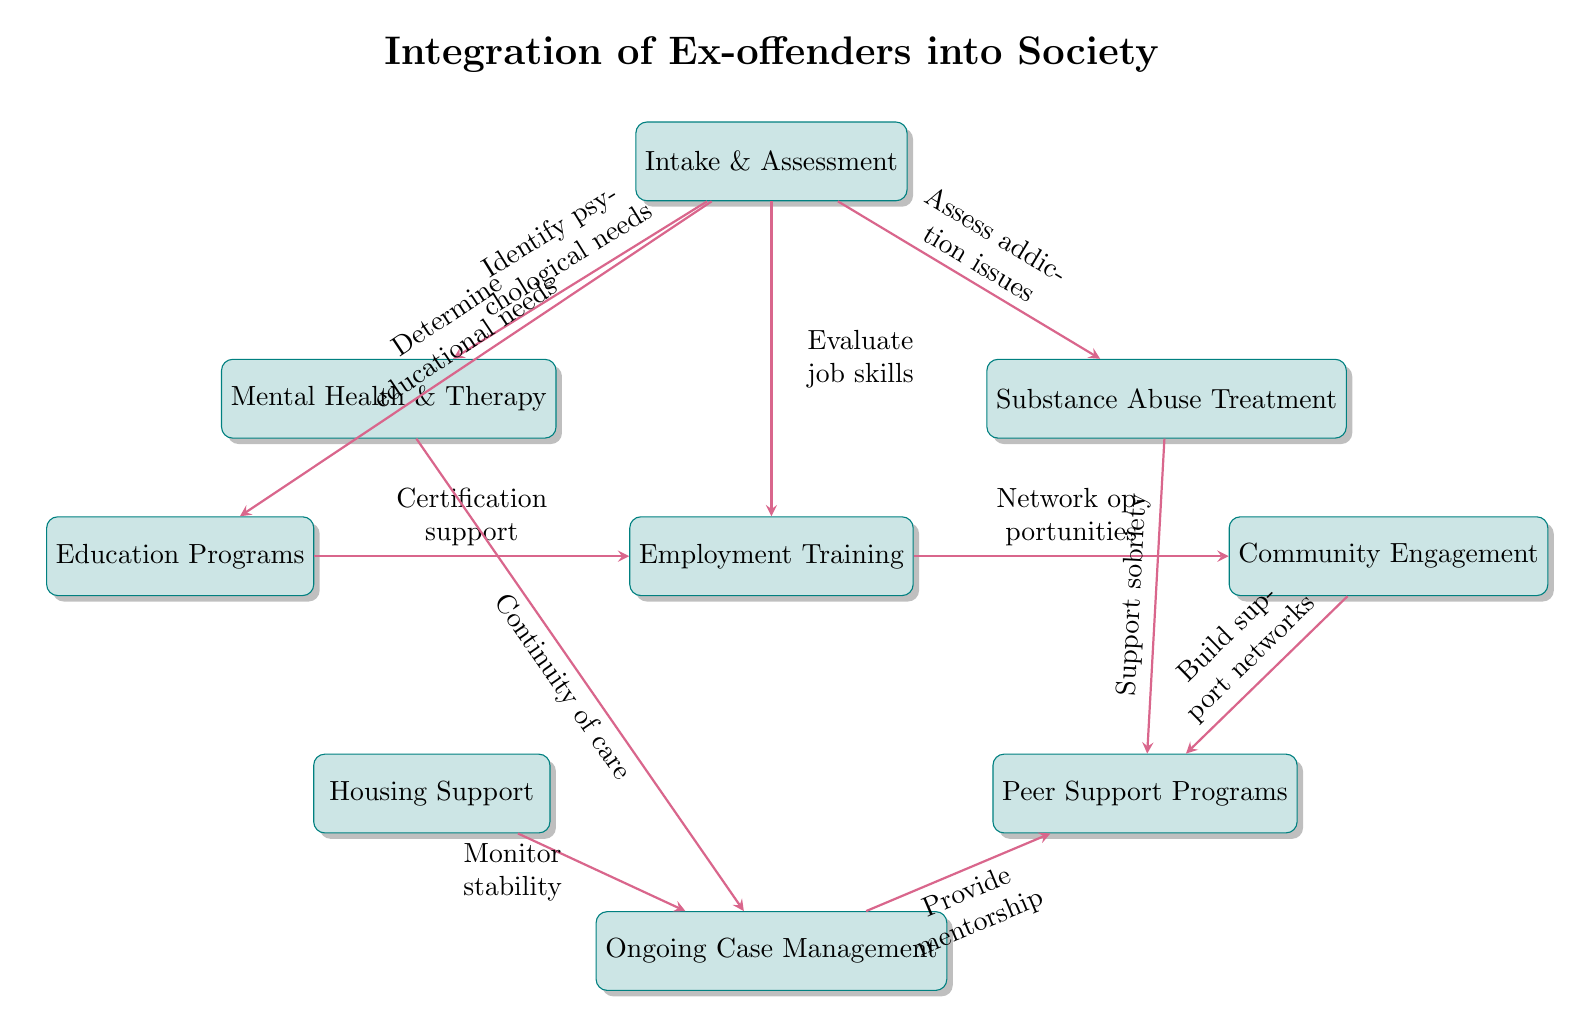What is the first process in the diagram? The first process is indicated at the top of the diagram, labeled "Intake & Assessment."
Answer: Intake & Assessment How many processes are listed in the diagram? There are a total of eight distinct processes mentioned in the diagram.
Answer: 8 What is the primary function of the "Mental Health & Therapy" process? It is connected to the "Intake & Assessment" process, where it helps identify psychological needs, indicating its primary function.
Answer: Identify psychological needs Which two processes provide support for sobriety? The "Substance Abuse Treatment" and "Peer Support Programs" directly contribute to maintaining sobriety as shown by their connections to other processes.
Answer: Substance Abuse Treatment, Peer Support Programs What is the relationship between "Education Programs" and "Employment Training"? "Education Programs" provides certification support to "Employment Training," indicating a collaborative function between these processes to enhance employability.
Answer: Certification support Which process comes after "Employment Training"? Following "Employment Training," the next process is "Ongoing Case Management," indicating a continual support system for the individuals.
Answer: Ongoing Case Management What is the role of "Community Engagement" in relation to employment? "Community Engagement" helps to network opportunities after "Employment Training," signifying its role in transitioning to job placement.
Answer: Network opportunities What process helps monitor stability in the diagram? The process labeled "Housing Support" is designated for monitoring stability, as it is connected to "Ongoing Case Management."
Answer: Housing Support 